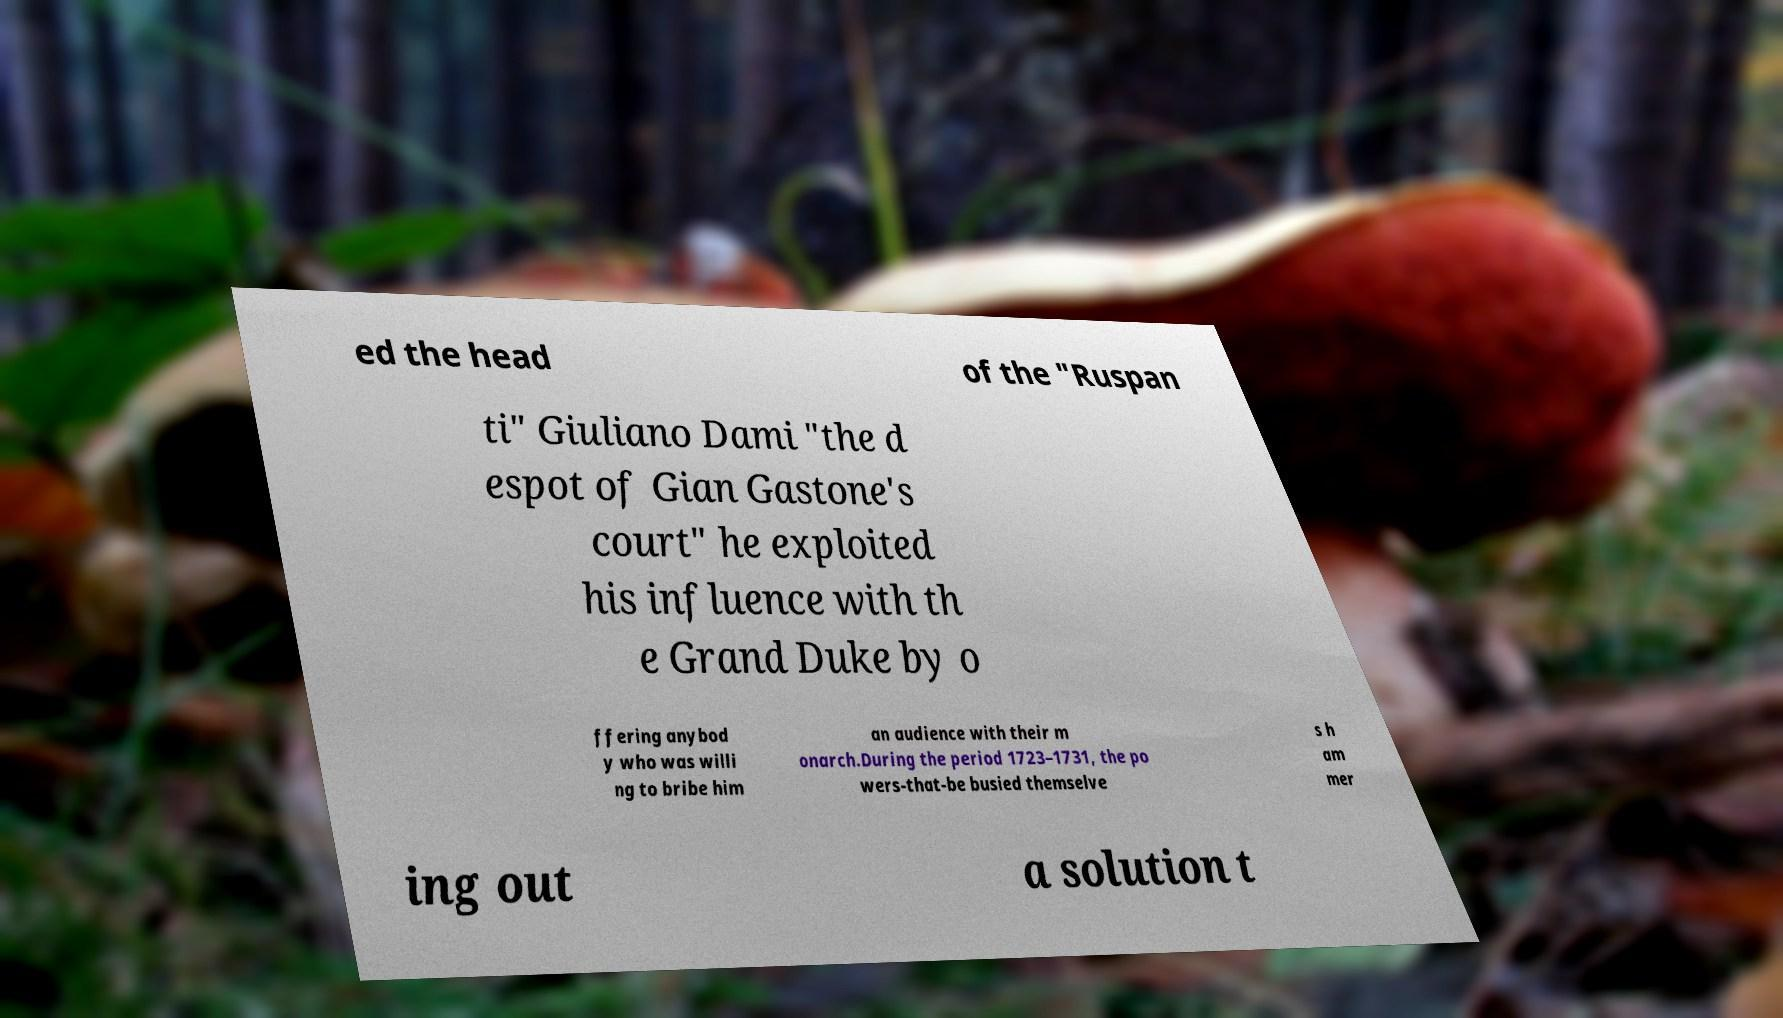I need the written content from this picture converted into text. Can you do that? ed the head of the "Ruspan ti" Giuliano Dami "the d espot of Gian Gastone's court" he exploited his influence with th e Grand Duke by o ffering anybod y who was willi ng to bribe him an audience with their m onarch.During the period 1723–1731, the po wers-that-be busied themselve s h am mer ing out a solution t 